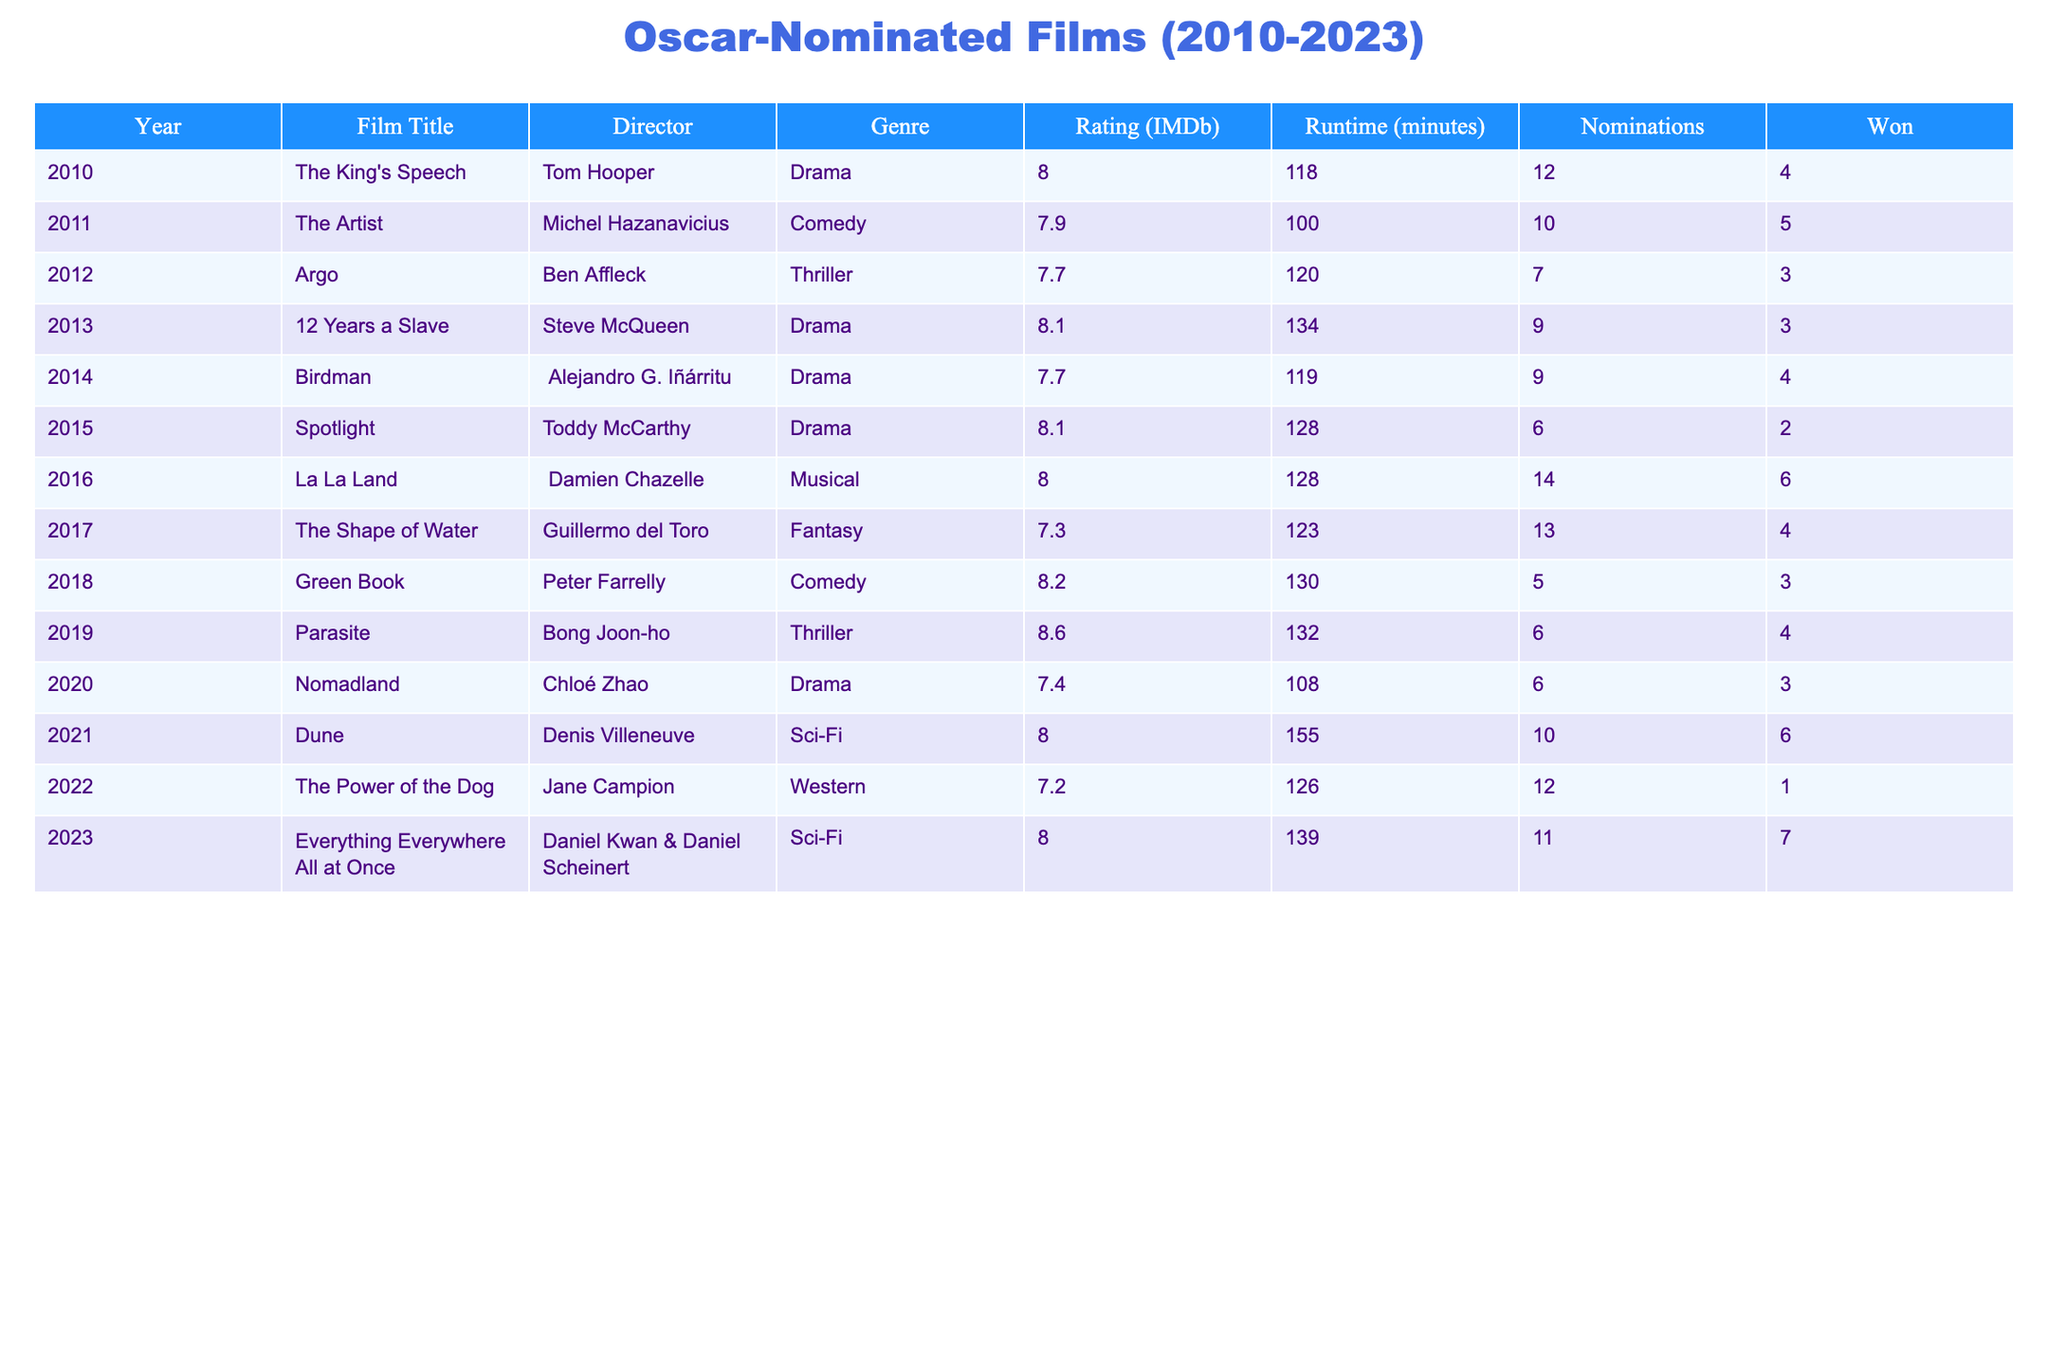What film won the most Oscars from 2010 to 2023? By scanning the "Won" column, I see that "The Artist" has the highest number of Oscars won, which is 5.
Answer: The Artist Which film from 2020 had the lowest IMDb rating? Looking at the "Rating (IMDb)" column for 2020, "Nomadland" has a rating of 7.4, which is lower than the other films from that year.
Answer: Nomadland What is the average IMDb rating for films that won more than 3 Oscars? First, I need to identify the films that won more than 3 Oscars: "The King's Speech" (8.0), "The Artist" (7.9), "La La Land" (8.0), and "Everything Everywhere All at Once" (8.0). I sum their ratings: 8.0 + 7.9 + 8.0 + 8.0 = 31.9. Dividing this by 4 gives an average rating of 31.9 / 4 = 7.975.
Answer: 7.975 Did any film released in 2018 win an Oscar? Referring to the rows corresponding to the year 2018, "Green Book" is noted for winning 3 Oscars, thus confirming that a film released in that year did win.
Answer: Yes What is the total runtime of all Oscar-nominated films from 2019 to 2023? I need to look at the "Runtime (minutes)" column for films released between 2019 and 2023: "Parasite" (132), "Nomadland" (108), "Dune" (155), "The Power of the Dog" (126), and "Everything Everywhere All at Once" (139). The total runtime is 132 + 108 + 155 + 126 + 139 = 660 minutes.
Answer: 660 minutes Which genre had the highest average IMDb rating among the films listed? I will calculate the average IMDb rating for each genre present: For "Drama," the films are "The King's Speech" (8.0), "12 Years a Slave" (8.1), "Spotlight" (8.1), "Nomadland" (7.4), resulting in an average rating of (8.0 + 8.1 + 8.1 + 7.4) / 4 = 7.85. For "Comedy," "The Artist" (7.9) and "Green Book" (8.2) yield an average of (7.9 + 8.2) / 2 = 8.05. Following this process for other genres concludes that the "Comedy" genre has the highest average with 8.05.
Answer: Comedy Which film had the highest number of nominations and how many? Looking closely at the "Nominations" column, "La La Land" had the highest with 14 nominations.
Answer: La La Land, 14 Was there a film nominated for an Oscar in 2013 that won more than 2 Oscars? The film "12 Years a Slave" from 2013 had 3 wins, which confirms it won more than 2 Oscars.
Answer: Yes 